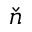<formula> <loc_0><loc_0><loc_500><loc_500>\check { n }</formula> 